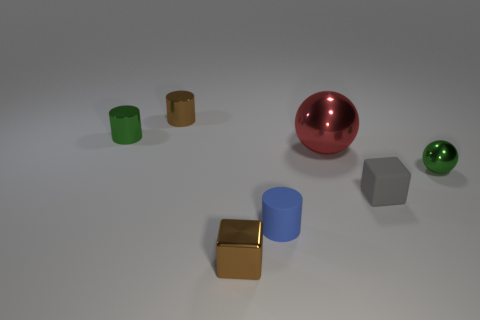What might be the purpose of these objects, given their shapes and materials? The objects depicted seem to be a collection of geometric shapes varying in materials, suggesting they might be used for decorative purposes, as part of a visual display, or perhaps in an educational context to demonstrate geometric forms and material properties. Their varied colors and surfaces could also make them ideal for a sensory play activity, which helps in the development of tactile perception and color recognition in learning environments. 